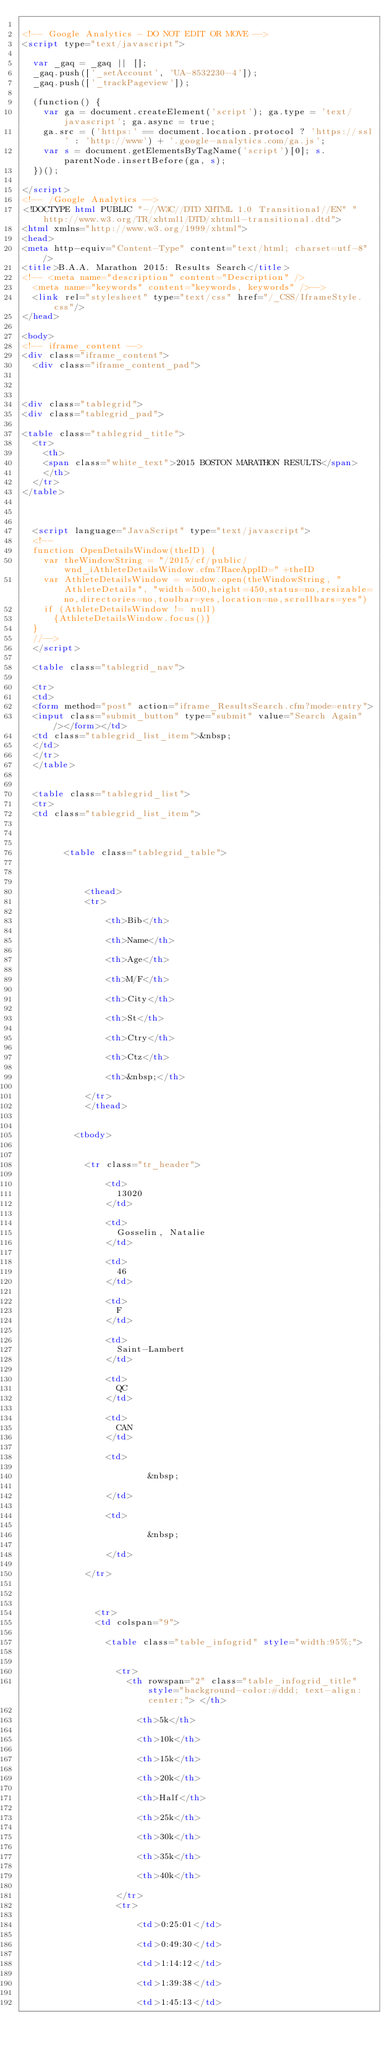<code> <loc_0><loc_0><loc_500><loc_500><_HTML_>
<!-- Google Analytics - DO NOT EDIT OR MOVE -->
<script type="text/javascript">

  var _gaq = _gaq || [];
  _gaq.push(['_setAccount', 'UA-8532230-4']);
  _gaq.push(['_trackPageview']);

  (function() {
    var ga = document.createElement('script'); ga.type = 'text/javascript'; ga.async = true;
    ga.src = ('https:' == document.location.protocol ? 'https://ssl' : 'http://www') + '.google-analytics.com/ga.js';
    var s = document.getElementsByTagName('script')[0]; s.parentNode.insertBefore(ga, s);
  })();

</script>
<!-- /Google Analytics -->
<!DOCTYPE html PUBLIC "-//W3C//DTD XHTML 1.0 Transitional//EN" "http://www.w3.org/TR/xhtml1/DTD/xhtml1-transitional.dtd">
<html xmlns="http://www.w3.org/1999/xhtml">
<head>
<meta http-equiv="Content-Type" content="text/html; charset=utf-8" />
<title>B.A.A. Marathon 2015: Results Search</title>
<!-- <meta name="description" content="Description" />
	<meta name="keywords" content="keywords, keywords" />-->
	<link rel="stylesheet" type="text/css" href="/_CSS/IframeStyle.css"/>
</head>

<body>
<!-- iframe_content -->
<div class="iframe_content">
	<div class="iframe_content_pad">

	

<div class="tablegrid">
<div class="tablegrid_pad">

<table class="tablegrid_title">
	<tr>
		<th>
		<span class="white_text">2015 BOSTON MARATHON RESULTS</span>
		</th>
	</tr>
</table>


	
	<script language="JavaScript" type="text/javascript">
	<!--
	function OpenDetailsWindow(theID) {
		var theWindowString = "/2015/cf/public/wnd_iAthleteDetailsWindow.cfm?RaceAppID=" +theID
		var AthleteDetailsWindow = window.open(theWindowString, "AthleteDetails", "width=500,height=450,status=no,resizable=no,directories=no,toolbar=yes,location=no,scrollbars=yes")
		if (AthleteDetailsWindow != null)
			{AthleteDetailsWindow.focus()}
	}
	//-->
	</script>

	<table class="tablegrid_nav">
	
	<tr>
	<td>
	<form method="post" action="iframe_ResultsSearch.cfm?mode=entry">
	<input class="submit_button" type="submit" value="Search Again"/></form></td>
	<td class="tablegrid_list_item">&nbsp;
	</td>
	</tr>
	</table>
	

	<table class="tablegrid_list">
	<tr>
	<td class="tablegrid_list_item">
	
	

				<table class="tablegrid_table">
					
					
					
						<thead>
						<tr>
							
								<th>Bib</th>
							
								<th>Name</th>
							
								<th>Age</th>
							
								<th>M/F</th>
							
								<th>City</th>
							
								<th>St</th>
							
								<th>Ctry</th>
							
								<th>Ctz</th>
							
								<th>&nbsp;</th>
							
						</tr>
						</thead>
						
					
					<tbody>
					
						
						<tr class="tr_header">
							
								<td>
									13020  
								</td>
							
								<td>
									Gosselin, Natalie  
								</td>
							
								<td>
									46  
								</td>
							
								<td>
									F  
								</td>
							
								<td>
									Saint-Lambert  
								</td>
							
								<td>
									QC  
								</td>
							
								<td>
									CAN  
								</td>
							
								<td>
									
												&nbsp; 
											 
								</td>
							
								<td>
									
												&nbsp; 
											 
								</td>
							
						</tr>
					
						
						
							<tr>
							<td colspan="9">
							
								<table class="table_infogrid" style="width:95%;">
								
									
									<tr>
										<th rowspan="2" class="table_infogrid_title" style="background-color:#ddd; text-align:center;"> </th>
										
											<th>5k</th>
										
											<th>10k</th>
										
											<th>15k</th>
										
											<th>20k</th>
										
											<th>Half</th>
										
											<th>25k</th>
										
											<th>30k</th>
										
											<th>35k</th>
										
											<th>40k</th>
										
									</tr>
									<tr>
										
											<td>0:25:01</td>
										
											<td>0:49:30</td>
										
											<td>1:14:12</td>
										
											<td>1:39:38</td>
										
											<td>1:45:13</td>
										</code> 